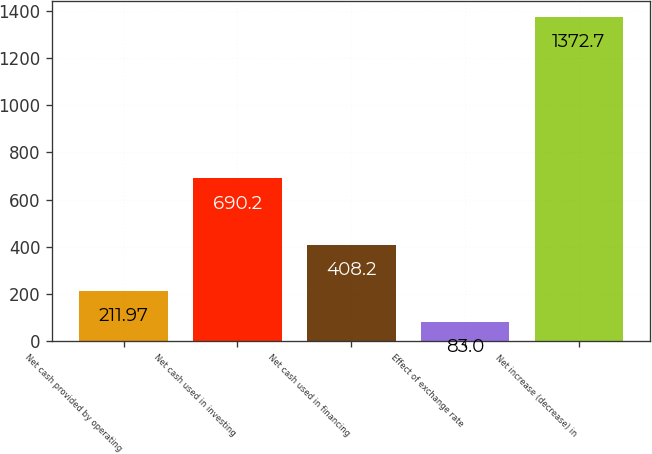Convert chart. <chart><loc_0><loc_0><loc_500><loc_500><bar_chart><fcel>Net cash provided by operating<fcel>Net cash used in investing<fcel>Net cash used in financing<fcel>Effect of exchange rate<fcel>Net increase (decrease) in<nl><fcel>211.97<fcel>690.2<fcel>408.2<fcel>83<fcel>1372.7<nl></chart> 